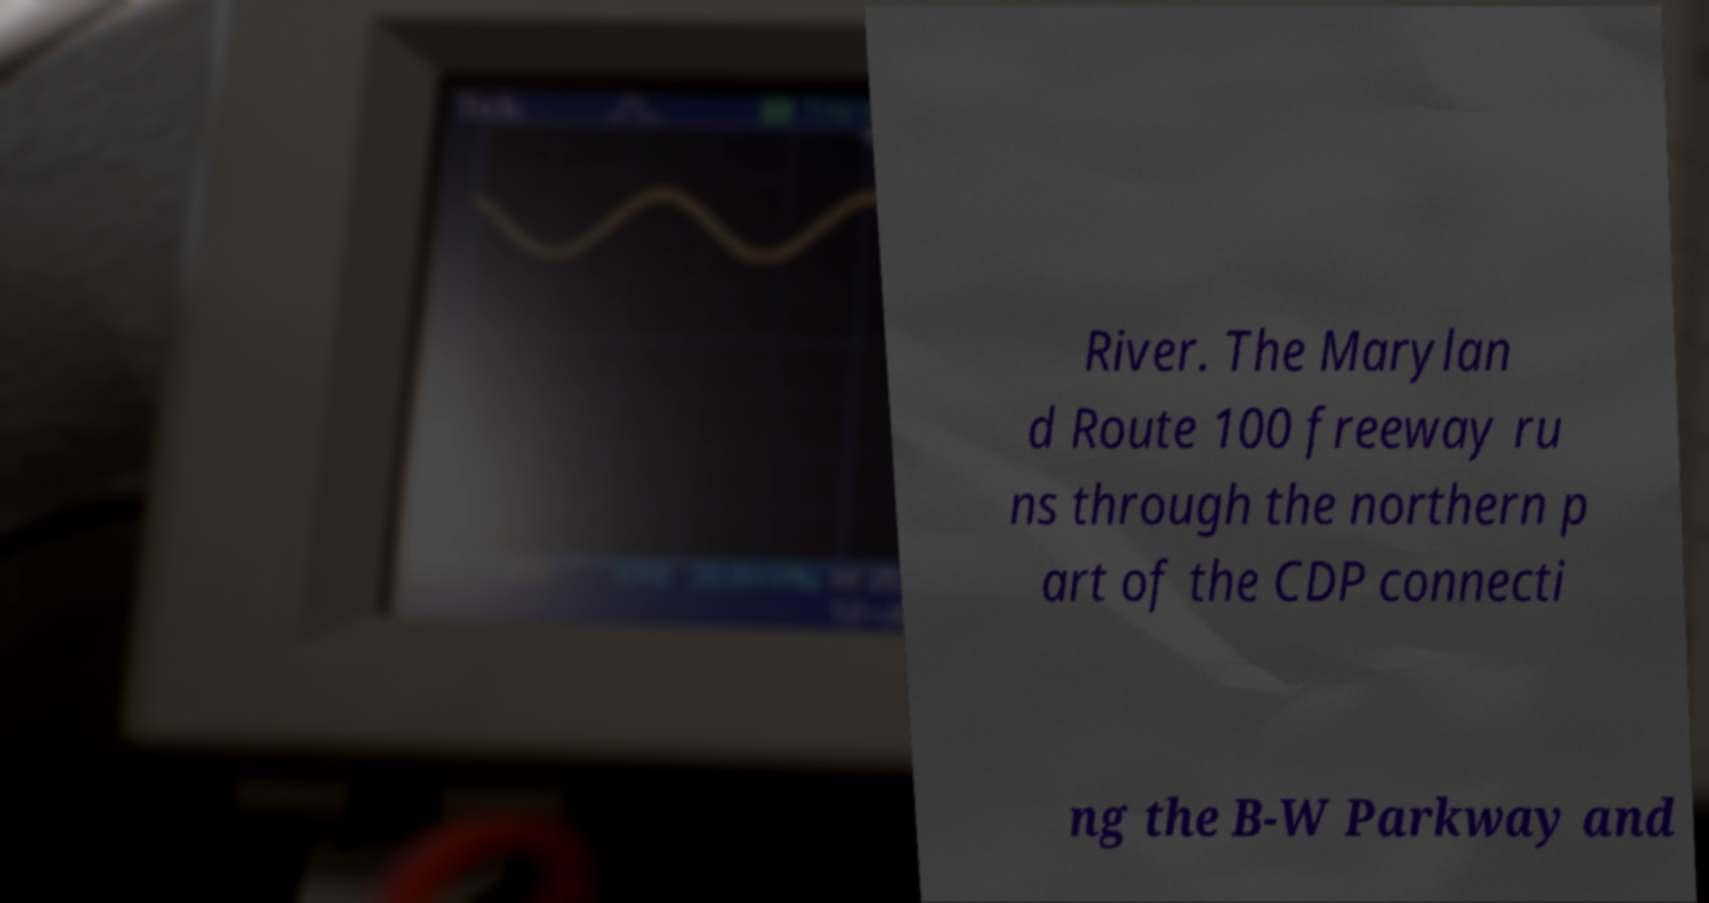I need the written content from this picture converted into text. Can you do that? River. The Marylan d Route 100 freeway ru ns through the northern p art of the CDP connecti ng the B-W Parkway and 